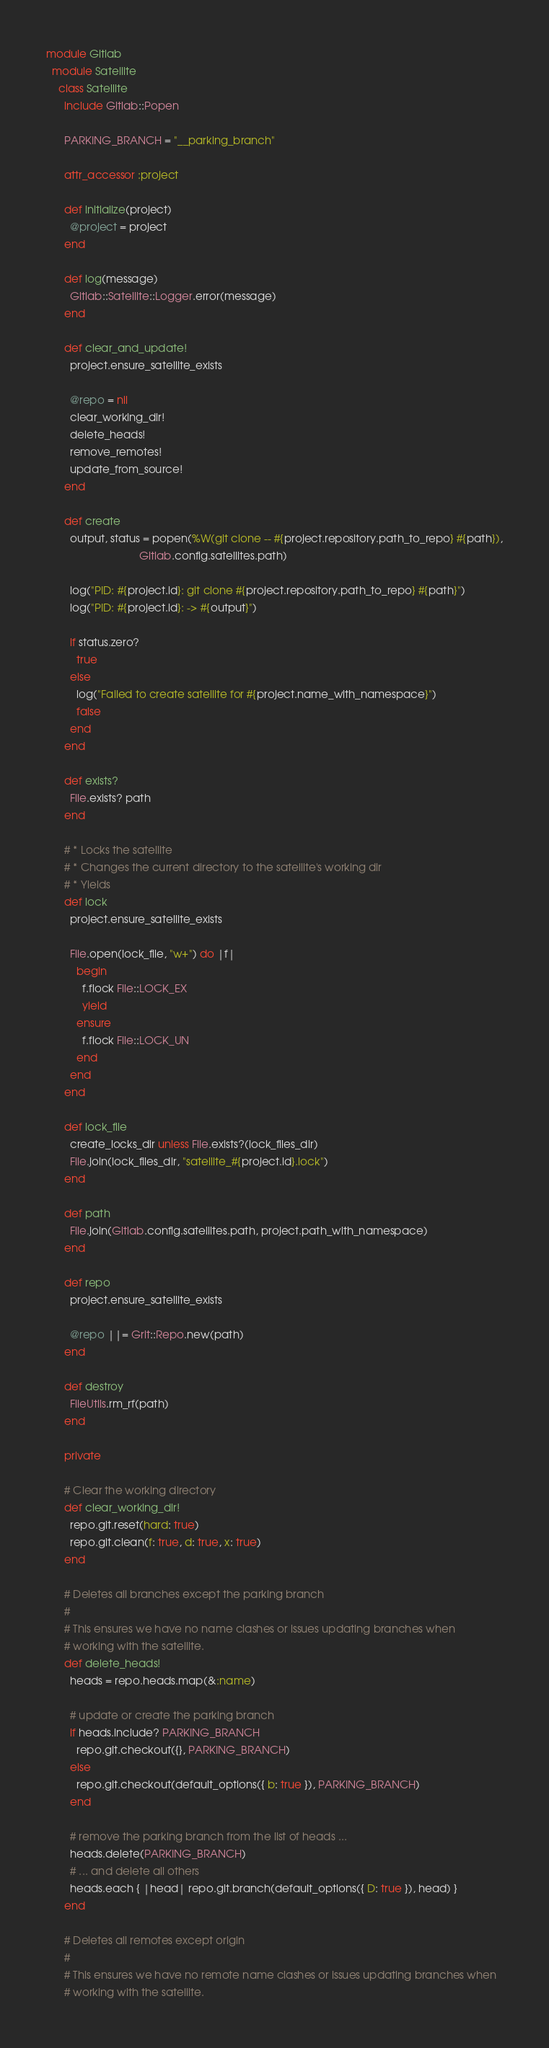<code> <loc_0><loc_0><loc_500><loc_500><_Ruby_>module Gitlab
  module Satellite
    class Satellite
      include Gitlab::Popen

      PARKING_BRANCH = "__parking_branch"

      attr_accessor :project

      def initialize(project)
        @project = project
      end

      def log(message)
        Gitlab::Satellite::Logger.error(message)
      end

      def clear_and_update!
        project.ensure_satellite_exists

        @repo = nil
        clear_working_dir!
        delete_heads!
        remove_remotes!
        update_from_source!
      end

      def create
        output, status = popen(%W(git clone -- #{project.repository.path_to_repo} #{path}),
                               Gitlab.config.satellites.path)

        log("PID: #{project.id}: git clone #{project.repository.path_to_repo} #{path}")
        log("PID: #{project.id}: -> #{output}")

        if status.zero?
          true
        else
          log("Failed to create satellite for #{project.name_with_namespace}")
          false
        end
      end

      def exists?
        File.exists? path
      end

      # * Locks the satellite
      # * Changes the current directory to the satellite's working dir
      # * Yields
      def lock
        project.ensure_satellite_exists

        File.open(lock_file, "w+") do |f|
          begin
            f.flock File::LOCK_EX
            yield
          ensure
            f.flock File::LOCK_UN
          end
        end
      end

      def lock_file
        create_locks_dir unless File.exists?(lock_files_dir)
        File.join(lock_files_dir, "satellite_#{project.id}.lock")
      end

      def path
        File.join(Gitlab.config.satellites.path, project.path_with_namespace)
      end

      def repo
        project.ensure_satellite_exists

        @repo ||= Grit::Repo.new(path)
      end

      def destroy
        FileUtils.rm_rf(path)
      end

      private

      # Clear the working directory
      def clear_working_dir!
        repo.git.reset(hard: true)
        repo.git.clean(f: true, d: true, x: true)
      end

      # Deletes all branches except the parking branch
      #
      # This ensures we have no name clashes or issues updating branches when
      # working with the satellite.
      def delete_heads!
        heads = repo.heads.map(&:name)

        # update or create the parking branch
        if heads.include? PARKING_BRANCH
          repo.git.checkout({}, PARKING_BRANCH)
        else
          repo.git.checkout(default_options({ b: true }), PARKING_BRANCH)
        end

        # remove the parking branch from the list of heads ...
        heads.delete(PARKING_BRANCH)
        # ... and delete all others
        heads.each { |head| repo.git.branch(default_options({ D: true }), head) }
      end

      # Deletes all remotes except origin
      #
      # This ensures we have no remote name clashes or issues updating branches when
      # working with the satellite.</code> 